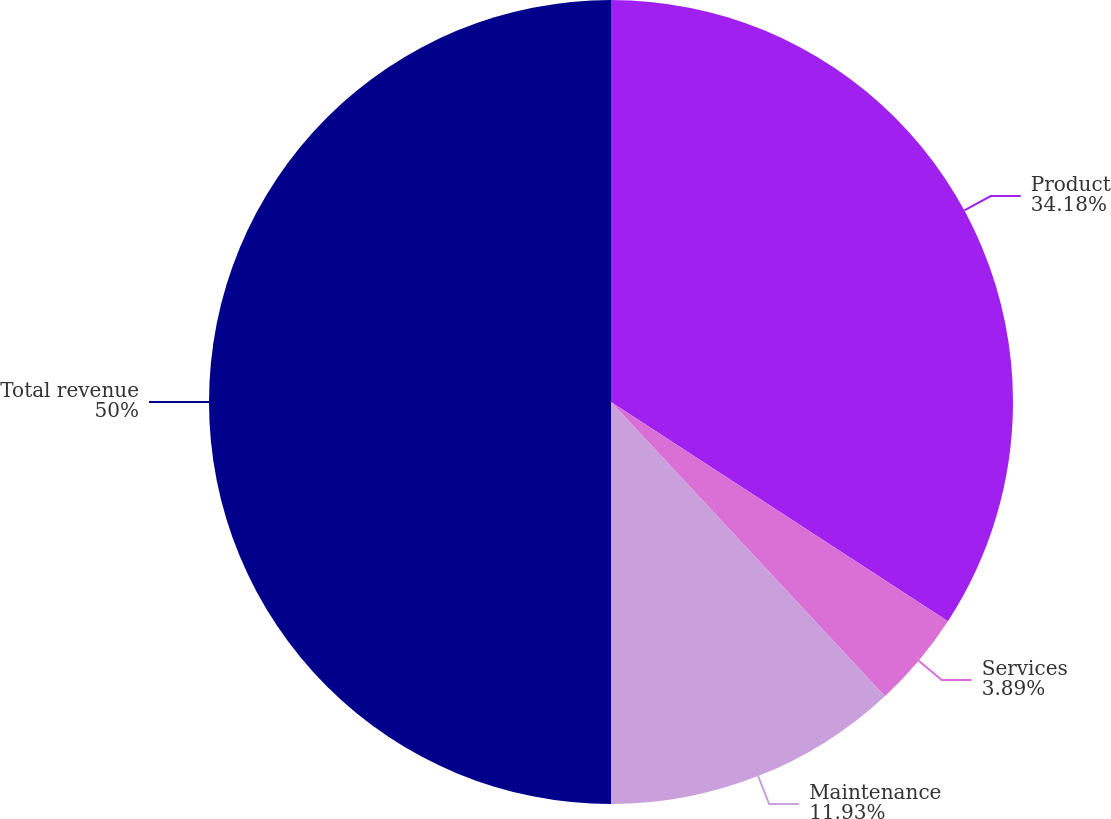Convert chart to OTSL. <chart><loc_0><loc_0><loc_500><loc_500><pie_chart><fcel>Product<fcel>Services<fcel>Maintenance<fcel>Total revenue<nl><fcel>34.18%<fcel>3.89%<fcel>11.93%<fcel>50.0%<nl></chart> 